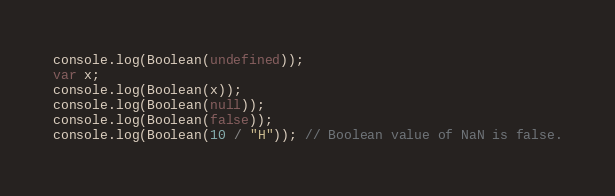Convert code to text. <code><loc_0><loc_0><loc_500><loc_500><_JavaScript_>console.log(Boolean(undefined));
var x;
console.log(Boolean(x));
console.log(Boolean(null));
console.log(Boolean(false));
console.log(Boolean(10 / "H")); // Boolean value of NaN is false.</code> 